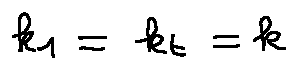<formula> <loc_0><loc_0><loc_500><loc_500>k _ { 1 } = k _ { t } = k</formula> 